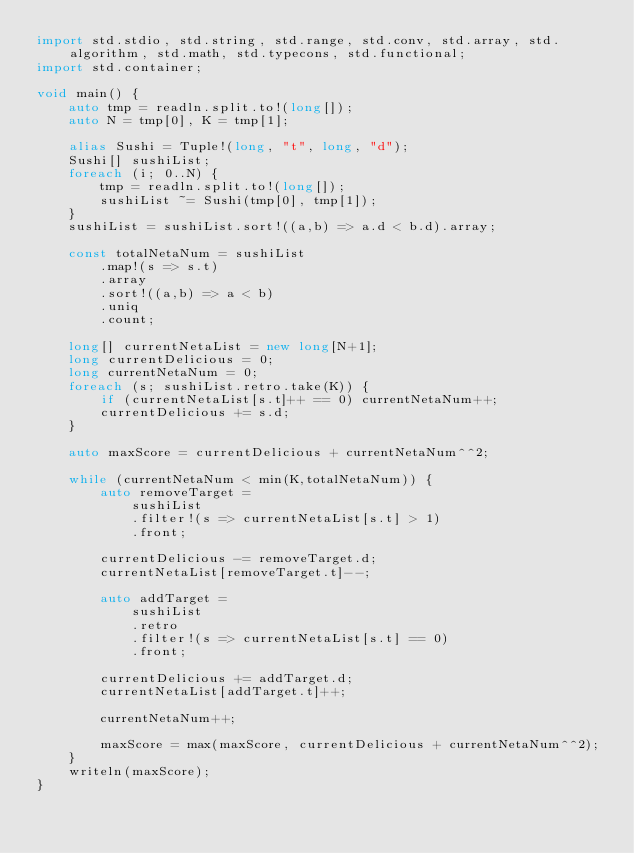Convert code to text. <code><loc_0><loc_0><loc_500><loc_500><_D_>import std.stdio, std.string, std.range, std.conv, std.array, std.algorithm, std.math, std.typecons, std.functional;
import std.container;

void main() {
    auto tmp = readln.split.to!(long[]);
    auto N = tmp[0], K = tmp[1];

    alias Sushi = Tuple!(long, "t", long, "d");
    Sushi[] sushiList;
    foreach (i; 0..N) {
        tmp = readln.split.to!(long[]);
        sushiList ~= Sushi(tmp[0], tmp[1]);
    }
    sushiList = sushiList.sort!((a,b) => a.d < b.d).array;

    const totalNetaNum = sushiList
        .map!(s => s.t)
        .array
        .sort!((a,b) => a < b)
        .uniq
        .count;

    long[] currentNetaList = new long[N+1];
    long currentDelicious = 0;
    long currentNetaNum = 0;
    foreach (s; sushiList.retro.take(K)) {
        if (currentNetaList[s.t]++ == 0) currentNetaNum++;
        currentDelicious += s.d;
    }

    auto maxScore = currentDelicious + currentNetaNum^^2;

    while (currentNetaNum < min(K,totalNetaNum)) {
        auto removeTarget =
            sushiList
            .filter!(s => currentNetaList[s.t] > 1)
            .front;

        currentDelicious -= removeTarget.d;
        currentNetaList[removeTarget.t]--;

        auto addTarget =
            sushiList
            .retro
            .filter!(s => currentNetaList[s.t] == 0)
            .front;

        currentDelicious += addTarget.d;
        currentNetaList[addTarget.t]++;

        currentNetaNum++;

        maxScore = max(maxScore, currentDelicious + currentNetaNum^^2);
    }
    writeln(maxScore);
}

</code> 